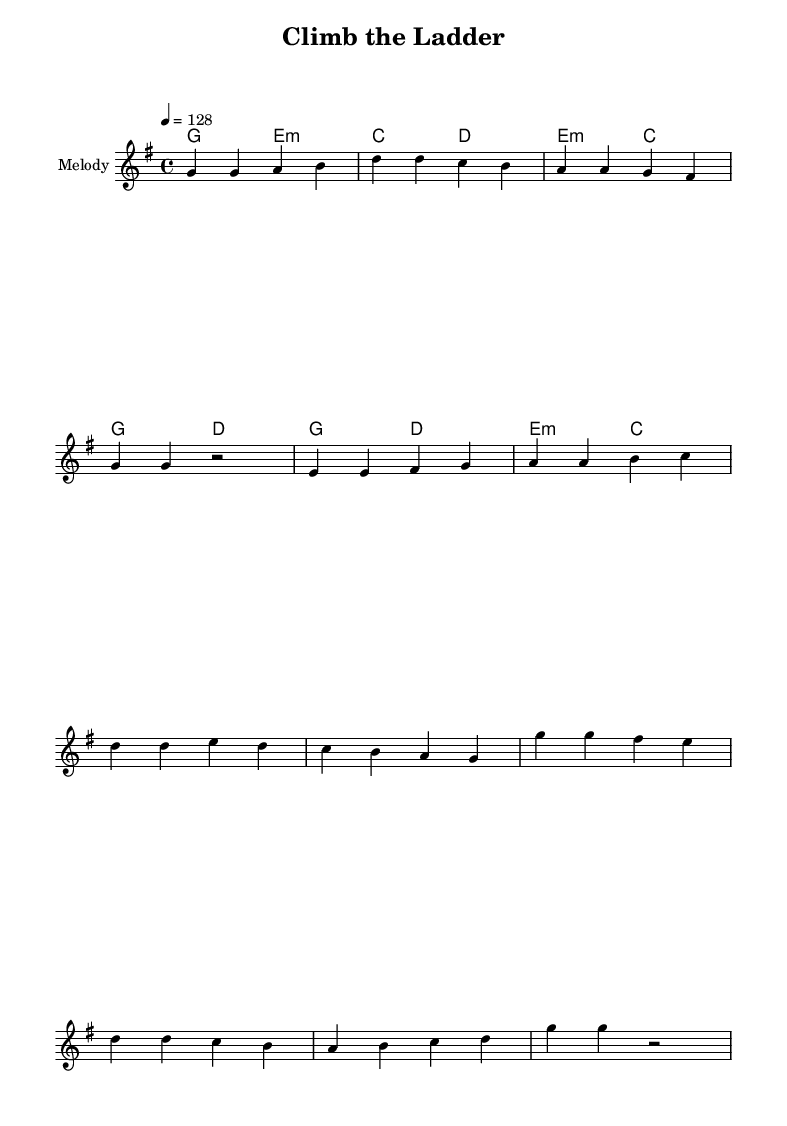What is the key signature of this music? The key signature is G major, which has one sharp (F#). This can be identified at the beginning of the score where the key signature is notated.
Answer: G major What is the time signature of this music? The time signature is 4/4, which indicates four beats per measure. This is shown at the beginning of the score following the key signature.
Answer: 4/4 What is the tempo marking for this piece? The tempo marking is 128 beats per minute, specified as “4 = 128” at the beginning of the score. This indicates how fast the piece should be played.
Answer: 128 How many sections does this music have? The music consists of three main sections: Verse, Pre-Chorus, and Chorus, which are clearly labeled and indicated in the lyrical part.
Answer: Three What is the primary theme of the lyrics? The primary theme focuses on navigating corporate politics and networking, as indicated by phrases about ambition, climbing the ladder, and making connections. This thematic content is evident through the lyrics presented in the score.
Answer: Corporate politics Which musical phrase responds to the lyrics "Net -- work, work it, don't you let it slip"? This phrase corresponds to the Chorus section, as indicated by the clear labeling and the lyrical structure that follows the melody notation. The lyrics convey the main message of the song in this section.
Answer: Chorus What chord follows the melody in the Verse? The chord that follows the melody in the Verse is E minor, as seen in the chord notation below the melody line in the score. This chord complements the mood and lyrics of the Verse.
Answer: E minor 